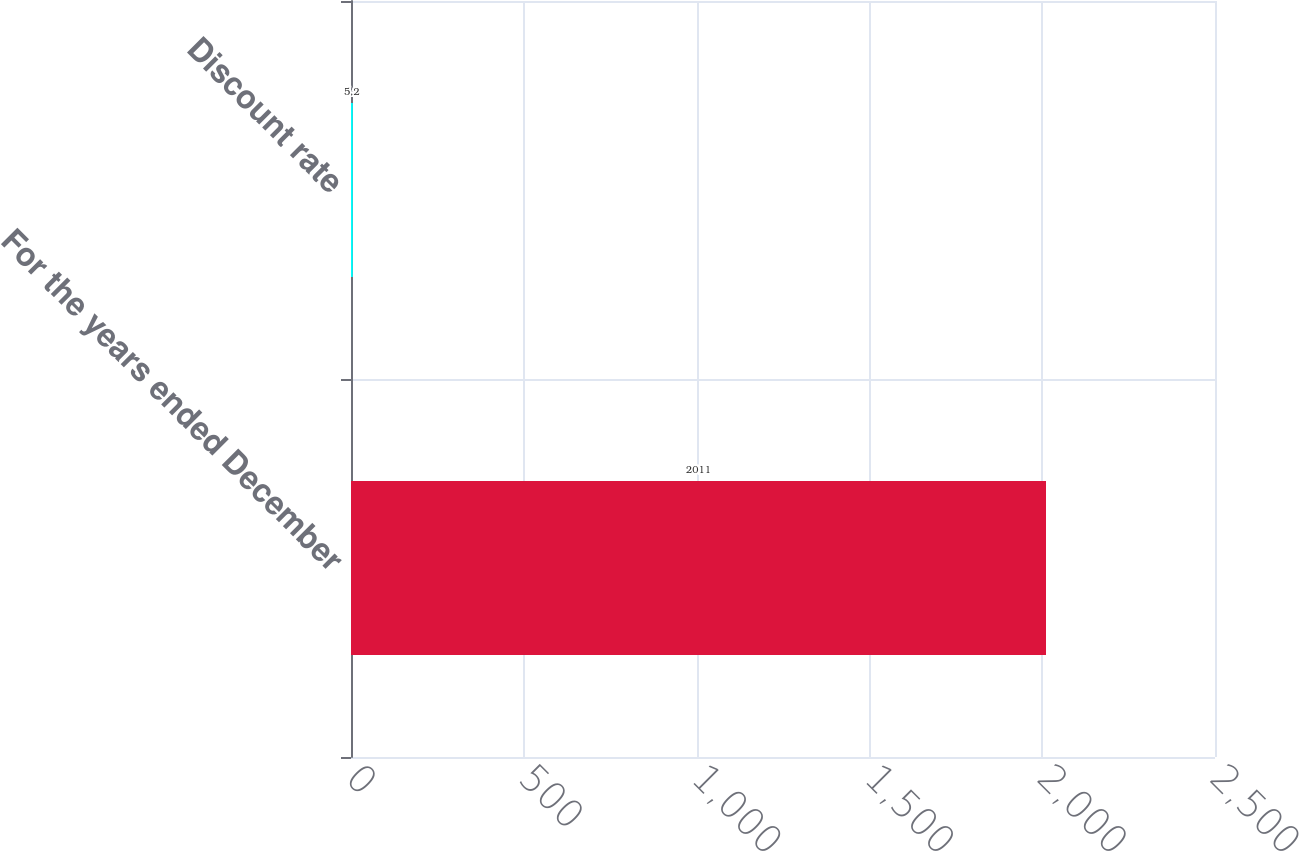Convert chart to OTSL. <chart><loc_0><loc_0><loc_500><loc_500><bar_chart><fcel>For the years ended December<fcel>Discount rate<nl><fcel>2011<fcel>5.2<nl></chart> 